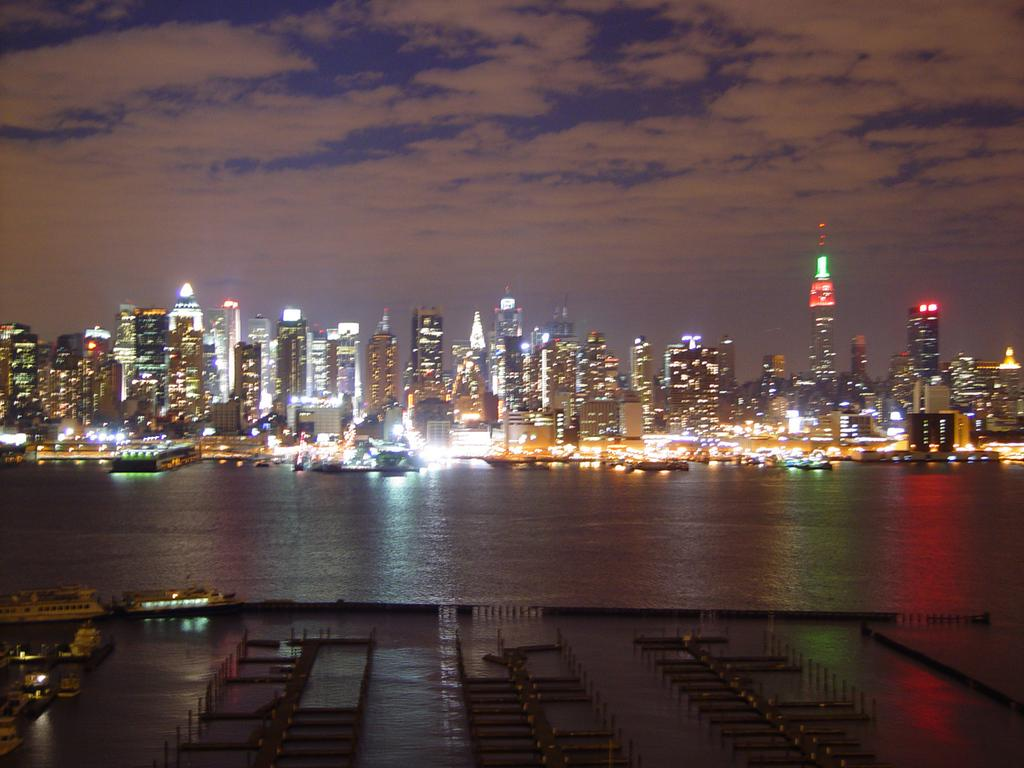What is present at the bottom of the image? There is water at the bottom side of the image. What type of buildings can be seen in the center of the image? There are skyscrapers in the center of the image. How many veins can be seen in the image? There are no veins present in the image. Are there any mice visible in the image? There are no mice present in the image. 